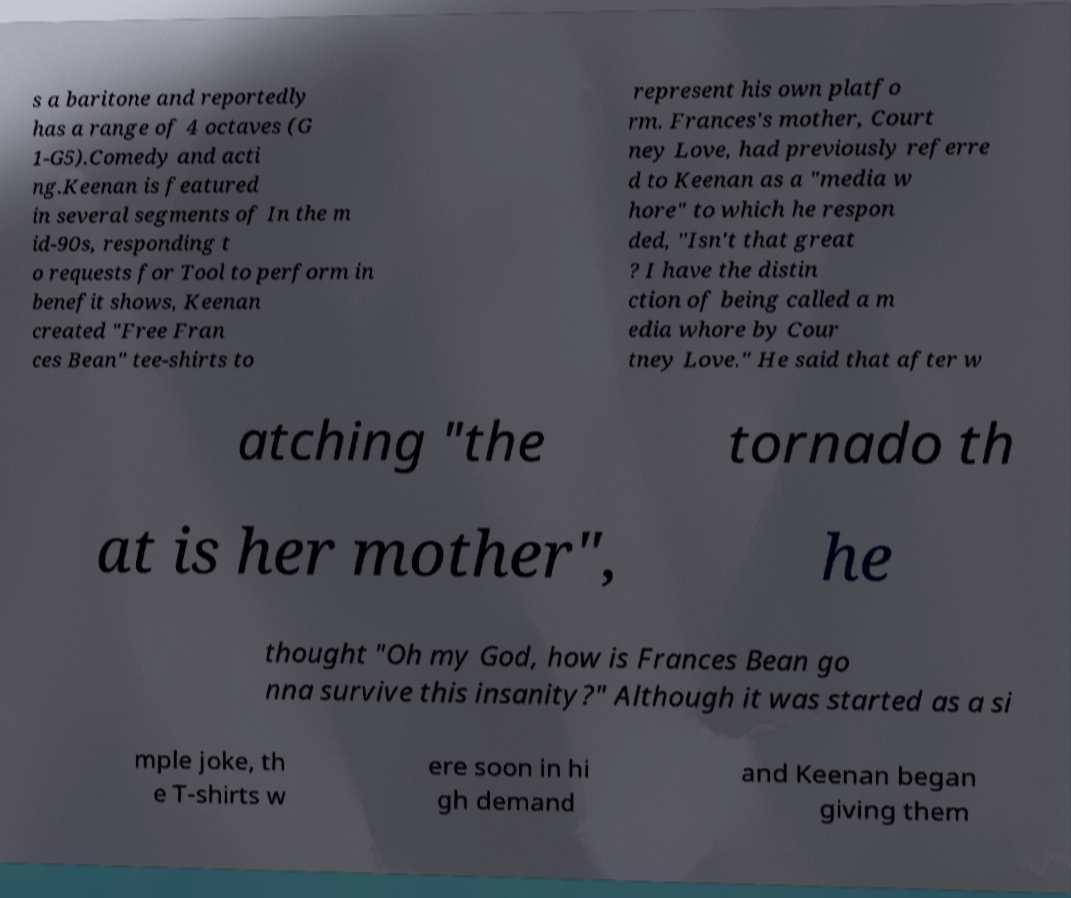Can you read and provide the text displayed in the image?This photo seems to have some interesting text. Can you extract and type it out for me? s a baritone and reportedly has a range of 4 octaves (G 1-G5).Comedy and acti ng.Keenan is featured in several segments of In the m id-90s, responding t o requests for Tool to perform in benefit shows, Keenan created "Free Fran ces Bean" tee-shirts to represent his own platfo rm. Frances's mother, Court ney Love, had previously referre d to Keenan as a "media w hore" to which he respon ded, "Isn't that great ? I have the distin ction of being called a m edia whore by Cour tney Love." He said that after w atching "the tornado th at is her mother", he thought "Oh my God, how is Frances Bean go nna survive this insanity?" Although it was started as a si mple joke, th e T-shirts w ere soon in hi gh demand and Keenan began giving them 